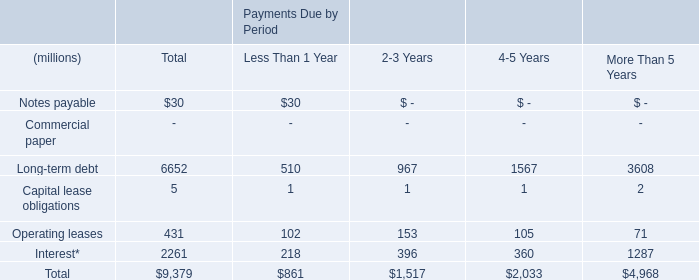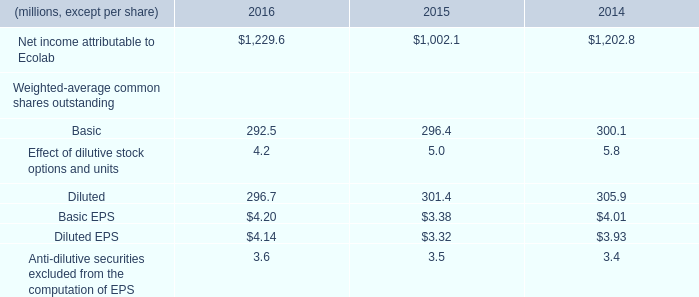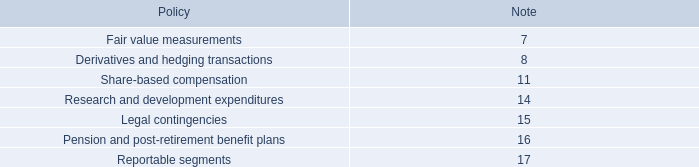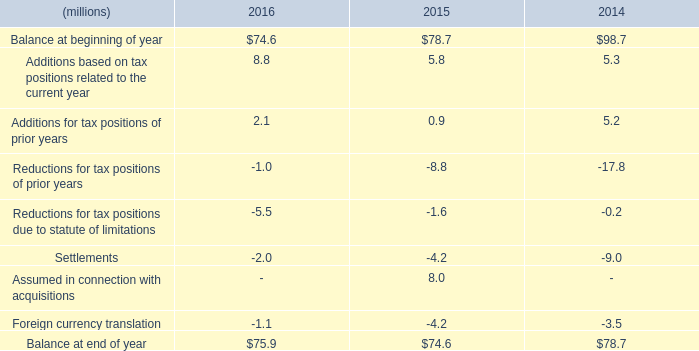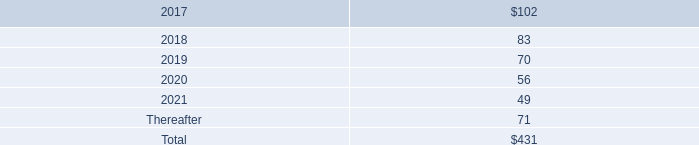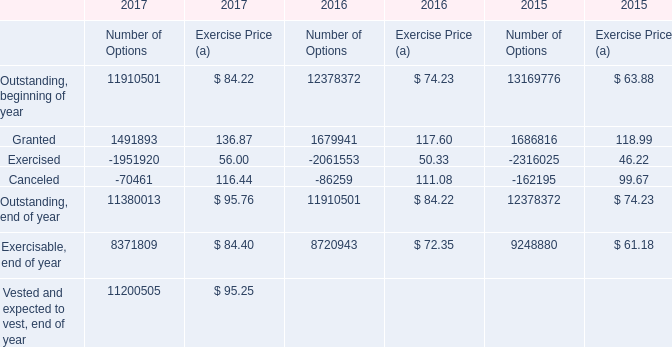what is the amount of credit lines that has been drawn in millions as of year-end 2016? 
Computations: (746 - 554)
Answer: 192.0. 